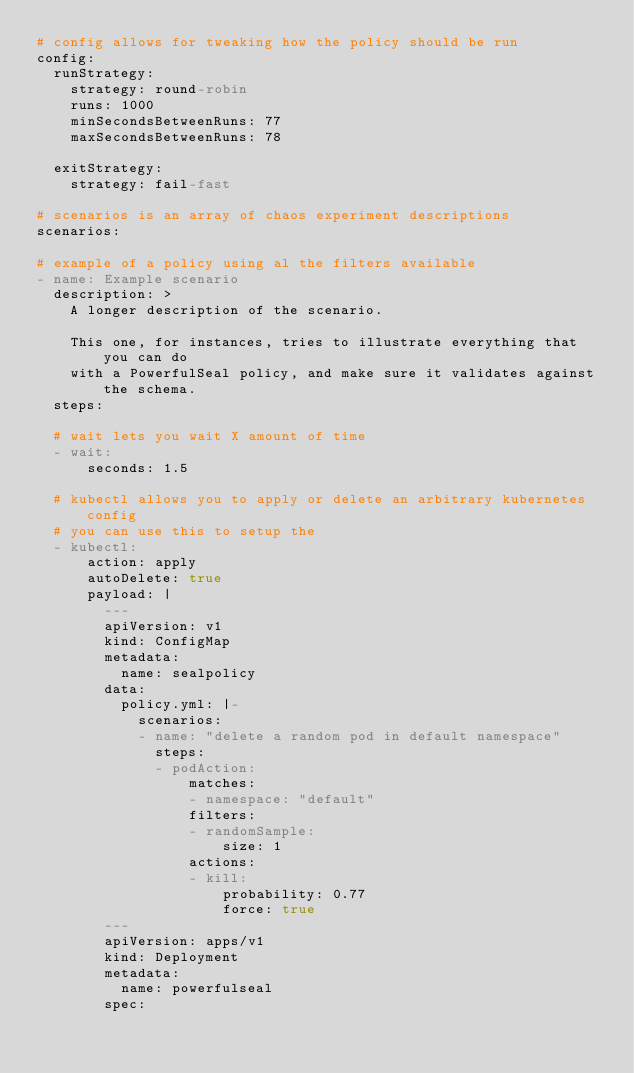<code> <loc_0><loc_0><loc_500><loc_500><_YAML_># config allows for tweaking how the policy should be run
config:
  runStrategy:
    strategy: round-robin
    runs: 1000
    minSecondsBetweenRuns: 77
    maxSecondsBetweenRuns: 78

  exitStrategy:
    strategy: fail-fast

# scenarios is an array of chaos experiment descriptions
scenarios:

# example of a policy using al the filters available
- name: Example scenario
  description: >
    A longer description of the scenario.

    This one, for instances, tries to illustrate everything that you can do
    with a PowerfulSeal policy, and make sure it validates against the schema.
  steps:

  # wait lets you wait X amount of time
  - wait:
      seconds: 1.5

  # kubectl allows you to apply or delete an arbitrary kubernetes config
  # you can use this to setup the
  - kubectl:
      action: apply
      autoDelete: true
      payload: |
        ---
        apiVersion: v1
        kind: ConfigMap
        metadata:
          name: sealpolicy
        data:
          policy.yml: |-
            scenarios:
            - name: "delete a random pod in default namespace"
              steps:
              - podAction:
                  matches:
                  - namespace: "default"
                  filters:
                  - randomSample:
                      size: 1
                  actions:
                  - kill:
                      probability: 0.77
                      force: true
        ---
        apiVersion: apps/v1
        kind: Deployment
        metadata:
          name: powerfulseal
        spec:</code> 